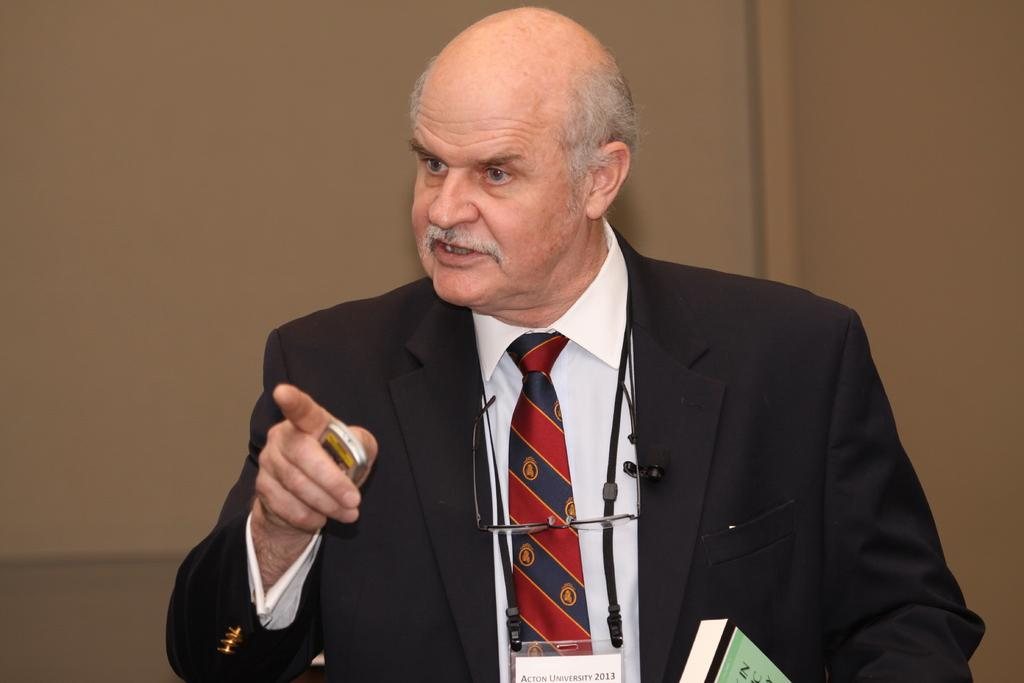Who is present in the image? There is a man in the image. What is the man wearing? The man is wearing a blazer and a tie. What is the man holding in his hand? The man is holding a device in his hand. What objects are in front of the man? There is a book and a pair of spectacles in front of the man. What can be seen in the background of the image? There is a wall in the background of the image. What type of cakes is the man eating in the image? There are no cakes present in the image; the man is holding a device and there is a book and a pair of spectacles in front of him. 